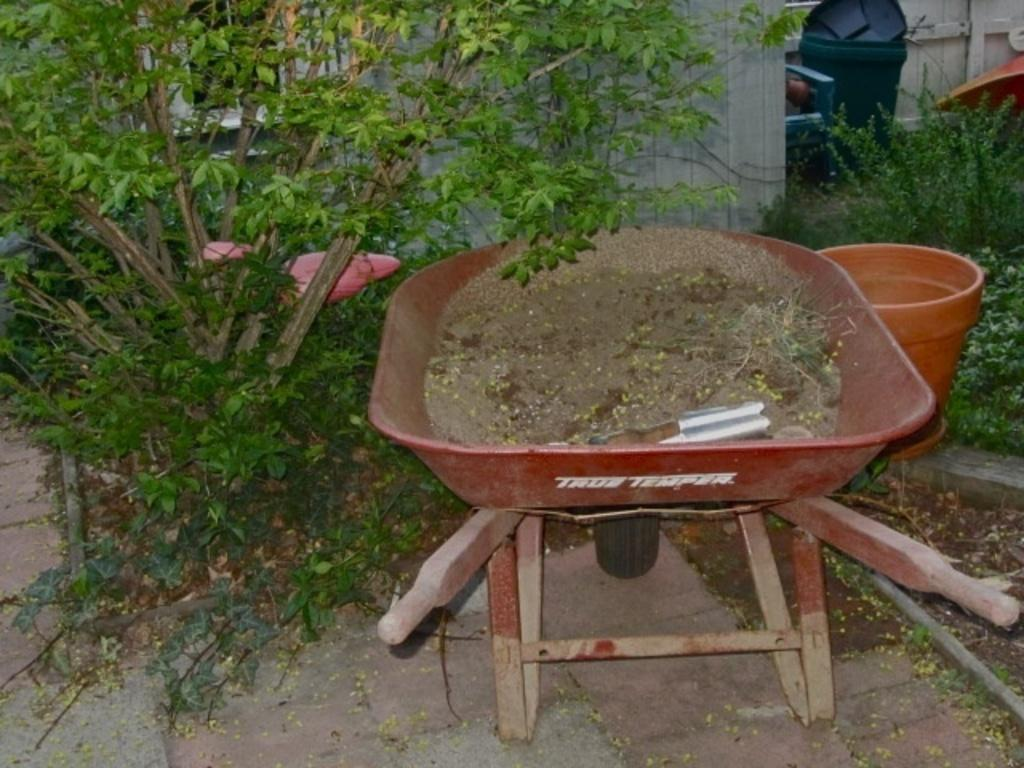What type of terrain is visible in the image? There is sand and grass visible in the image. What is placed in a cart in the image? There is an object in a cart in the image. What can be seen in the background of the image? In the background, there are plants, a bucket, a dustbin, and a chair. Are there any other objects visible in the background? Yes, there are other objects visible in the background. What type of sea creatures can be seen swimming in the image? There is no sea or sea creatures present in the image; it features sand, grass, and various objects. Is there a prison visible in the image? No, there is no prison present in the image. 